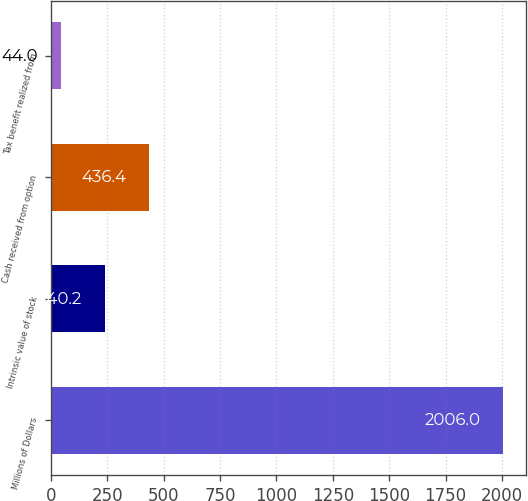<chart> <loc_0><loc_0><loc_500><loc_500><bar_chart><fcel>Millions of Dollars<fcel>Intrinsic value of stock<fcel>Cash received from option<fcel>Tax benefit realized from<nl><fcel>2006<fcel>240.2<fcel>436.4<fcel>44<nl></chart> 